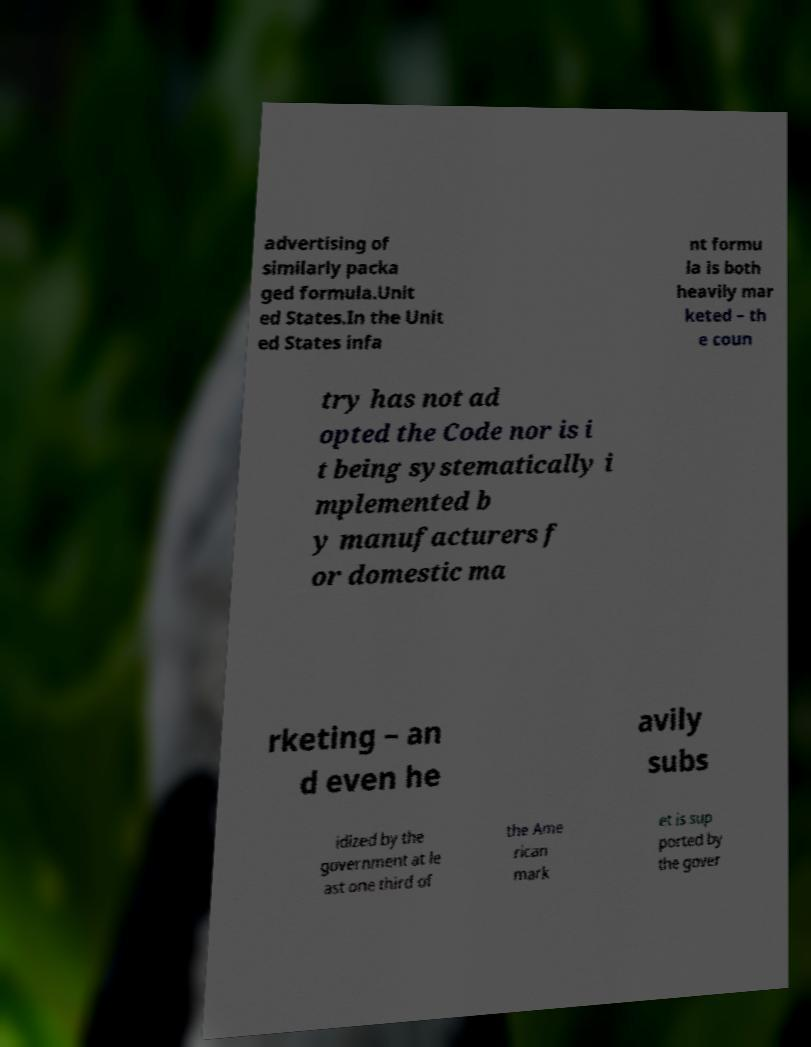Could you assist in decoding the text presented in this image and type it out clearly? advertising of similarly packa ged formula.Unit ed States.In the Unit ed States infa nt formu la is both heavily mar keted – th e coun try has not ad opted the Code nor is i t being systematically i mplemented b y manufacturers f or domestic ma rketing – an d even he avily subs idized by the government at le ast one third of the Ame rican mark et is sup ported by the gover 